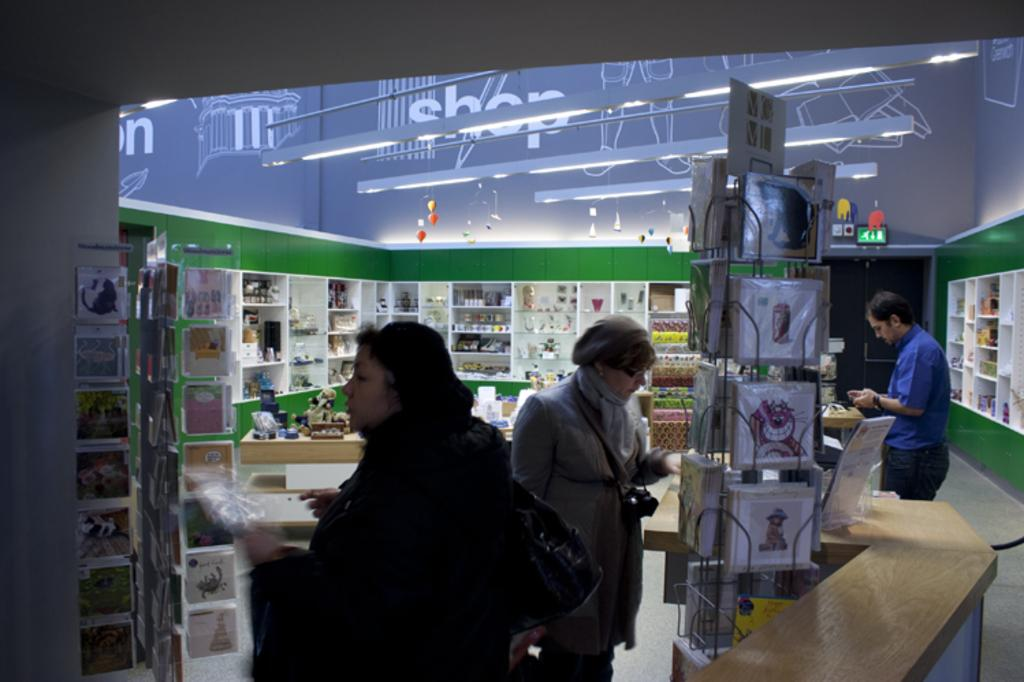<image>
Write a terse but informative summary of the picture. People shopping in a store with the word "SHOP" on the ceiling. 